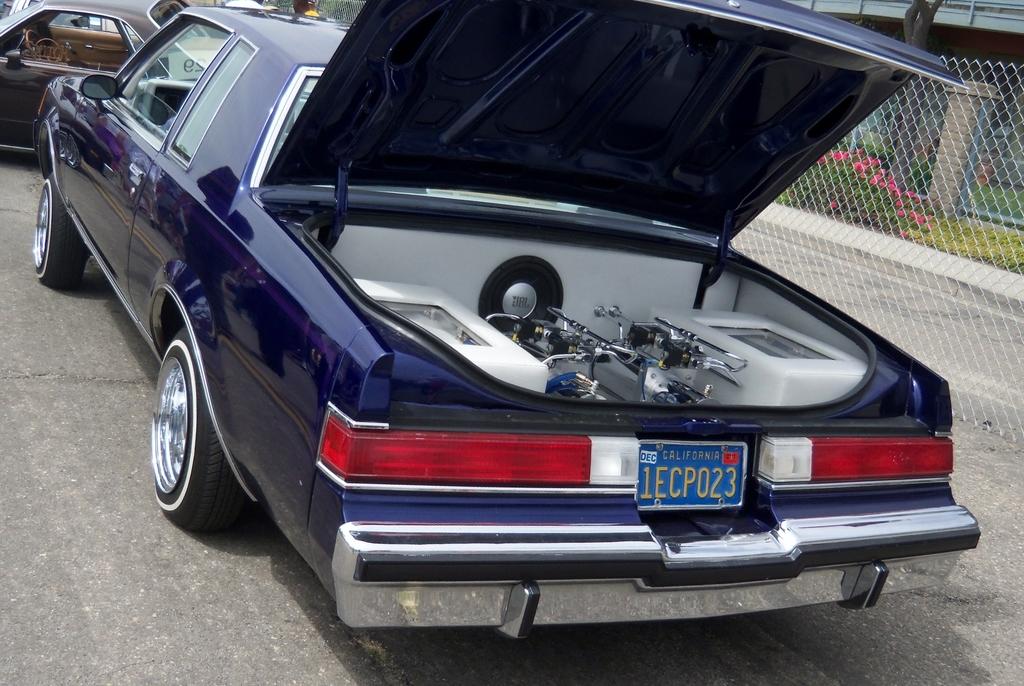What does the license plate say?
Offer a terse response. 1ecp023. What state is this car licensed in?
Ensure brevity in your answer.  California. 